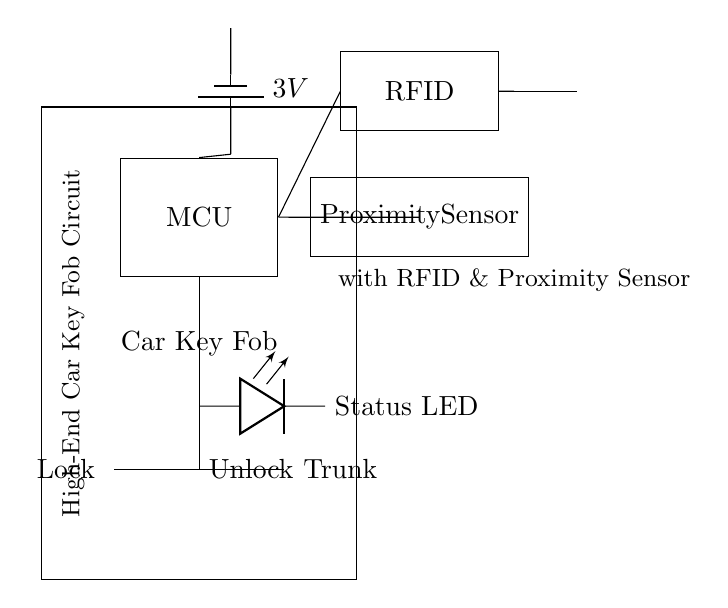What is the voltage of this circuit? The voltage is 3V, indicated near the battery component in the diagram.
Answer: 3V What components are present in this circuit? The components include a battery, microcontroller, RFID circuit, antenna, proximity sensor, status LED, and push buttons for lock, unlock, and trunk.
Answer: Battery, microcontroller, RFID circuit, antenna, proximity sensor, LED, buttons Which component controls the locking mechanism? The locking mechanism is controlled by the push button labeled "Lock," which is connected to the microcontroller.
Answer: Lock button What is the function of the antenna? The antenna is used for transmitting and receiving signals in the RFID circuit, allowing communication between the key fob and the car's locking system.
Answer: Communication How does the proximity sensor interact with the microcontroller? The proximity sensor sends data to the microcontroller, which processes the information regarding the distance of the key fob from the vehicle to enable or disable the locking mechanism.
Answer: Processes distance data What happens when the unlock button is pressed? When the unlock button is pressed, it sends a signal to the microcontroller, which then activates the mechanism to unlock the car doors.
Answer: Unlocks car doors How is the status of the circuit indicated? The status of the circuit is indicated by the status LED, which lights up based on the operational state managed by the microcontroller.
Answer: Status LED 